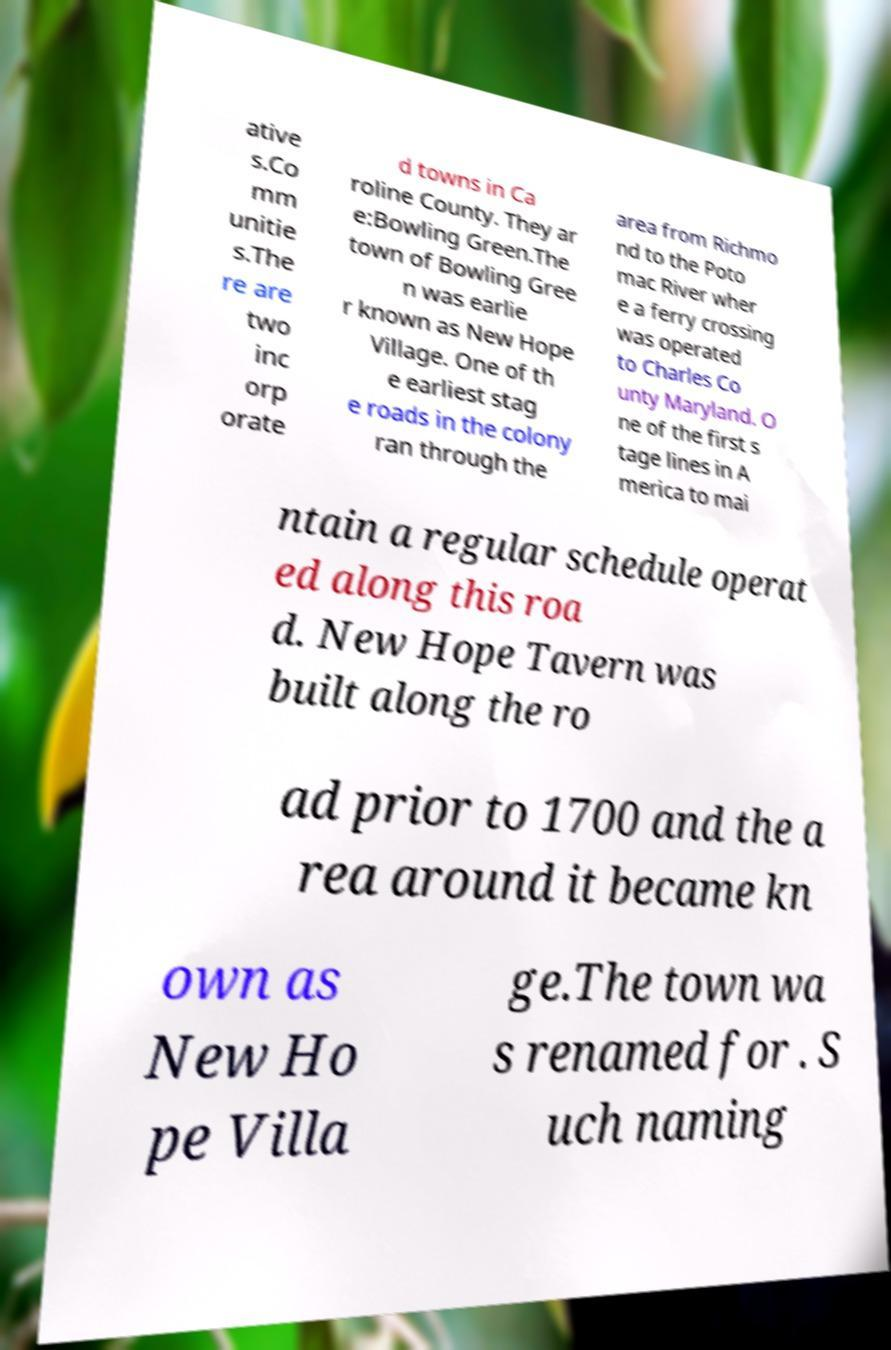I need the written content from this picture converted into text. Can you do that? ative s.Co mm unitie s.The re are two inc orp orate d towns in Ca roline County. They ar e:Bowling Green.The town of Bowling Gree n was earlie r known as New Hope Village. One of th e earliest stag e roads in the colony ran through the area from Richmo nd to the Poto mac River wher e a ferry crossing was operated to Charles Co unty Maryland. O ne of the first s tage lines in A merica to mai ntain a regular schedule operat ed along this roa d. New Hope Tavern was built along the ro ad prior to 1700 and the a rea around it became kn own as New Ho pe Villa ge.The town wa s renamed for . S uch naming 